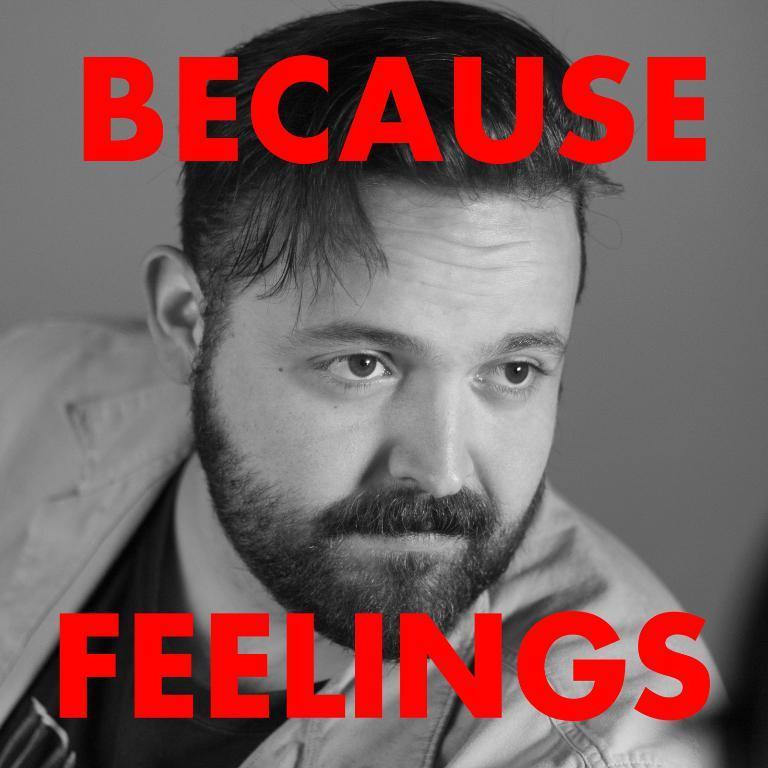In one or two sentences, can you explain what this image depicts? This picture is an edited picture. In this image there is a person with black t-shirt and there is a text at the top and there is a text at the bottom. 